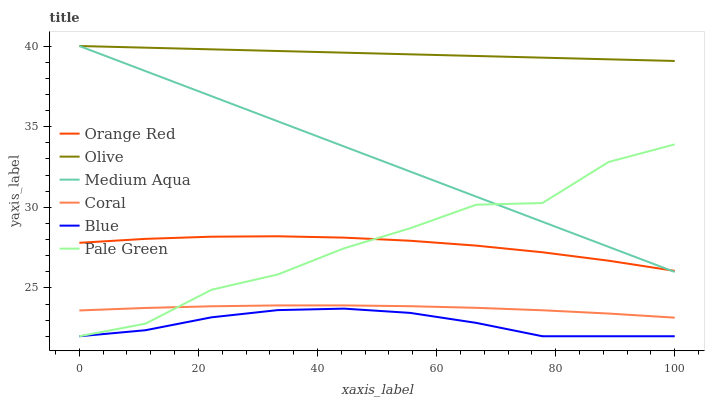Does Blue have the minimum area under the curve?
Answer yes or no. Yes. Does Olive have the maximum area under the curve?
Answer yes or no. Yes. Does Coral have the minimum area under the curve?
Answer yes or no. No. Does Coral have the maximum area under the curve?
Answer yes or no. No. Is Olive the smoothest?
Answer yes or no. Yes. Is Pale Green the roughest?
Answer yes or no. Yes. Is Coral the smoothest?
Answer yes or no. No. Is Coral the roughest?
Answer yes or no. No. Does Blue have the lowest value?
Answer yes or no. Yes. Does Coral have the lowest value?
Answer yes or no. No. Does Olive have the highest value?
Answer yes or no. Yes. Does Coral have the highest value?
Answer yes or no. No. Is Coral less than Medium Aqua?
Answer yes or no. Yes. Is Olive greater than Coral?
Answer yes or no. Yes. Does Orange Red intersect Medium Aqua?
Answer yes or no. Yes. Is Orange Red less than Medium Aqua?
Answer yes or no. No. Is Orange Red greater than Medium Aqua?
Answer yes or no. No. Does Coral intersect Medium Aqua?
Answer yes or no. No. 